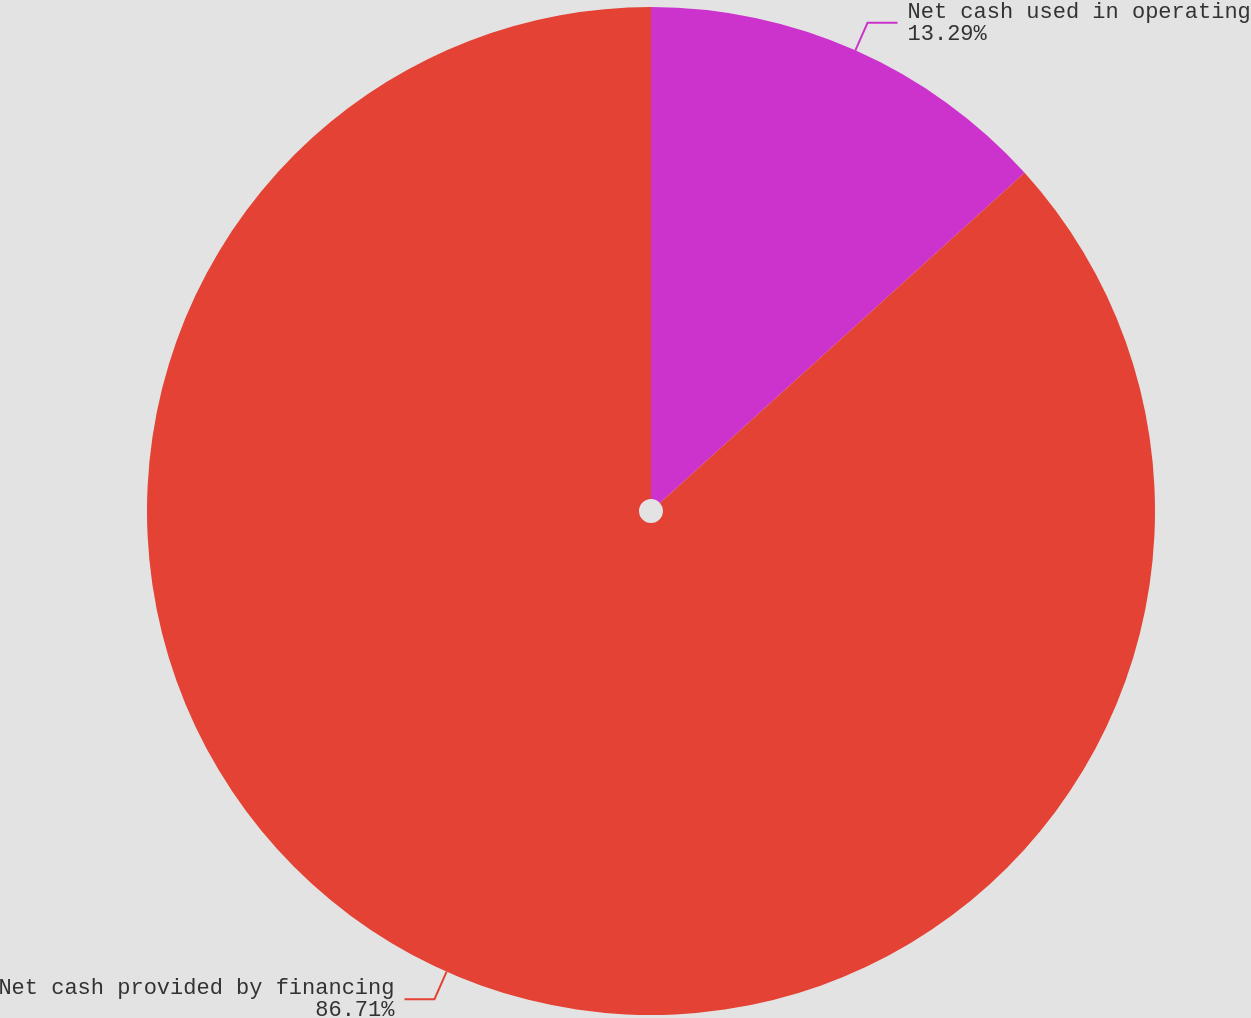Convert chart to OTSL. <chart><loc_0><loc_0><loc_500><loc_500><pie_chart><fcel>Net cash used in operating<fcel>Net cash provided by financing<nl><fcel>13.29%<fcel>86.71%<nl></chart> 